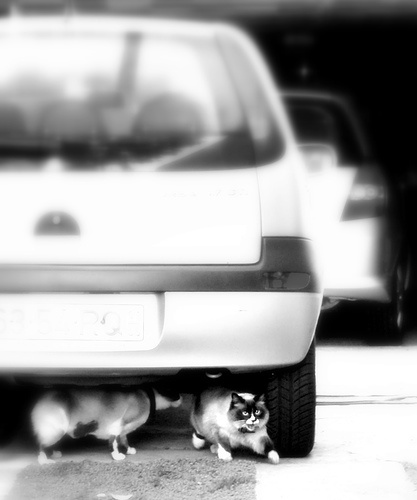Describe the objects in this image and their specific colors. I can see car in gray, white, darkgray, and black tones, car in gray, black, white, and darkgray tones, cat in gray, black, darkgray, and lightgray tones, and cat in gray, black, lightgray, and darkgray tones in this image. 